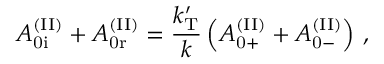Convert formula to latex. <formula><loc_0><loc_0><loc_500><loc_500>A _ { 0 i } ^ { ( I I ) } + A _ { 0 r } ^ { ( I I ) } = \frac { k _ { T } ^ { \prime } } { k } \left ( A _ { 0 + } ^ { ( I I ) } + A _ { 0 - } ^ { ( I I ) } \right ) \, ,</formula> 